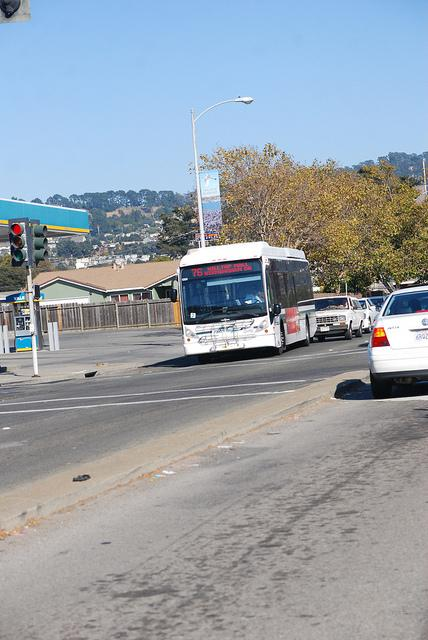Which vehicle is leading the ones on the left side? Please explain your reasoning. bus. There is a big passenger bus leading on the left side. 